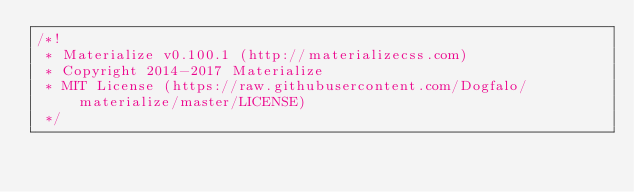Convert code to text. <code><loc_0><loc_0><loc_500><loc_500><_CSS_>/*!
 * Materialize v0.100.1 (http://materializecss.com)
 * Copyright 2014-2017 Materialize
 * MIT License (https://raw.githubusercontent.com/Dogfalo/materialize/master/LICENSE)
 */</code> 